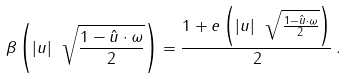Convert formula to latex. <formula><loc_0><loc_0><loc_500><loc_500>\beta \left ( | u | \ \sqrt { \frac { 1 - \hat { u } \cdot \omega } { 2 } } \right ) = \frac { 1 + e \left ( | u | \ \sqrt { \frac { 1 - \hat { u } \cdot \omega } { 2 } } \right ) } { 2 } \, .</formula> 